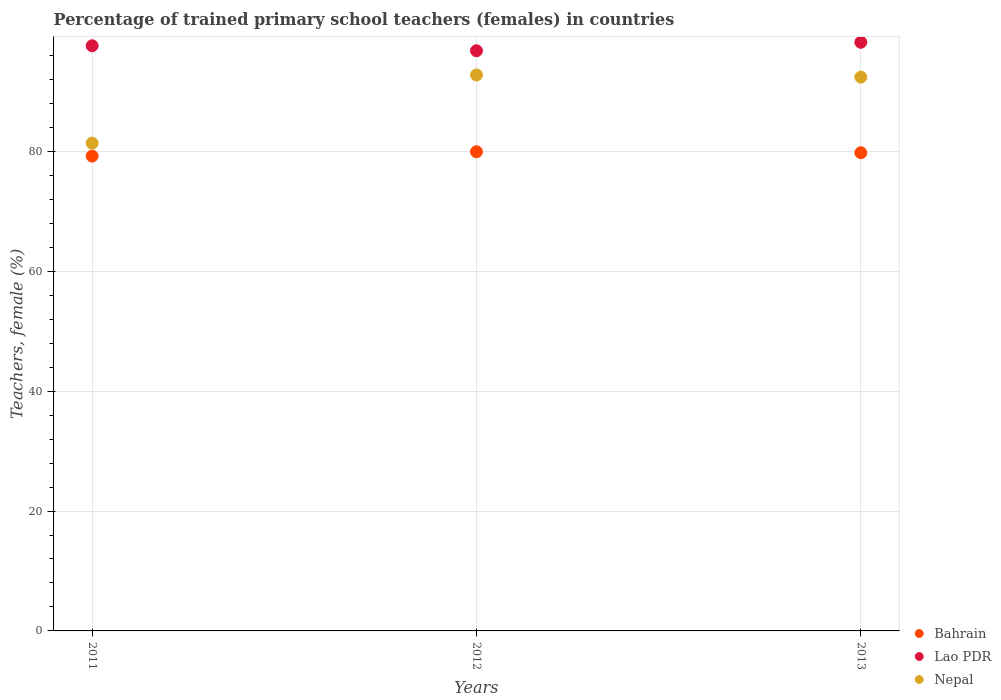What is the percentage of trained primary school teachers (females) in Lao PDR in 2013?
Your response must be concise. 98.19. Across all years, what is the maximum percentage of trained primary school teachers (females) in Nepal?
Give a very brief answer. 92.74. Across all years, what is the minimum percentage of trained primary school teachers (females) in Lao PDR?
Offer a terse response. 96.78. In which year was the percentage of trained primary school teachers (females) in Nepal maximum?
Ensure brevity in your answer.  2012. In which year was the percentage of trained primary school teachers (females) in Nepal minimum?
Offer a terse response. 2011. What is the total percentage of trained primary school teachers (females) in Bahrain in the graph?
Give a very brief answer. 238.91. What is the difference between the percentage of trained primary school teachers (females) in Nepal in 2012 and that in 2013?
Offer a terse response. 0.36. What is the difference between the percentage of trained primary school teachers (females) in Nepal in 2013 and the percentage of trained primary school teachers (females) in Lao PDR in 2012?
Ensure brevity in your answer.  -4.4. What is the average percentage of trained primary school teachers (females) in Lao PDR per year?
Ensure brevity in your answer.  97.53. In the year 2011, what is the difference between the percentage of trained primary school teachers (females) in Nepal and percentage of trained primary school teachers (females) in Bahrain?
Your response must be concise. 2.17. What is the ratio of the percentage of trained primary school teachers (females) in Bahrain in 2011 to that in 2013?
Give a very brief answer. 0.99. What is the difference between the highest and the second highest percentage of trained primary school teachers (females) in Bahrain?
Provide a succinct answer. 0.16. What is the difference between the highest and the lowest percentage of trained primary school teachers (females) in Lao PDR?
Provide a succinct answer. 1.42. Is the sum of the percentage of trained primary school teachers (females) in Lao PDR in 2011 and 2012 greater than the maximum percentage of trained primary school teachers (females) in Bahrain across all years?
Offer a very short reply. Yes. Is it the case that in every year, the sum of the percentage of trained primary school teachers (females) in Nepal and percentage of trained primary school teachers (females) in Bahrain  is greater than the percentage of trained primary school teachers (females) in Lao PDR?
Provide a succinct answer. Yes. Is the percentage of trained primary school teachers (females) in Lao PDR strictly less than the percentage of trained primary school teachers (females) in Bahrain over the years?
Provide a succinct answer. No. What is the difference between two consecutive major ticks on the Y-axis?
Provide a short and direct response. 20. Does the graph contain any zero values?
Your answer should be compact. No. What is the title of the graph?
Your answer should be very brief. Percentage of trained primary school teachers (females) in countries. Does "Ecuador" appear as one of the legend labels in the graph?
Ensure brevity in your answer.  No. What is the label or title of the X-axis?
Give a very brief answer. Years. What is the label or title of the Y-axis?
Your answer should be very brief. Teachers, female (%). What is the Teachers, female (%) of Bahrain in 2011?
Keep it short and to the point. 79.2. What is the Teachers, female (%) in Lao PDR in 2011?
Make the answer very short. 97.61. What is the Teachers, female (%) of Nepal in 2011?
Offer a terse response. 81.37. What is the Teachers, female (%) in Bahrain in 2012?
Keep it short and to the point. 79.93. What is the Teachers, female (%) in Lao PDR in 2012?
Keep it short and to the point. 96.78. What is the Teachers, female (%) of Nepal in 2012?
Give a very brief answer. 92.74. What is the Teachers, female (%) of Bahrain in 2013?
Your response must be concise. 79.77. What is the Teachers, female (%) in Lao PDR in 2013?
Make the answer very short. 98.19. What is the Teachers, female (%) in Nepal in 2013?
Your response must be concise. 92.38. Across all years, what is the maximum Teachers, female (%) of Bahrain?
Give a very brief answer. 79.93. Across all years, what is the maximum Teachers, female (%) in Lao PDR?
Ensure brevity in your answer.  98.19. Across all years, what is the maximum Teachers, female (%) in Nepal?
Ensure brevity in your answer.  92.74. Across all years, what is the minimum Teachers, female (%) of Bahrain?
Keep it short and to the point. 79.2. Across all years, what is the minimum Teachers, female (%) in Lao PDR?
Offer a very short reply. 96.78. Across all years, what is the minimum Teachers, female (%) in Nepal?
Offer a very short reply. 81.37. What is the total Teachers, female (%) of Bahrain in the graph?
Provide a succinct answer. 238.91. What is the total Teachers, female (%) in Lao PDR in the graph?
Provide a succinct answer. 292.59. What is the total Teachers, female (%) in Nepal in the graph?
Provide a short and direct response. 266.49. What is the difference between the Teachers, female (%) of Bahrain in 2011 and that in 2012?
Your answer should be compact. -0.73. What is the difference between the Teachers, female (%) in Lao PDR in 2011 and that in 2012?
Ensure brevity in your answer.  0.83. What is the difference between the Teachers, female (%) in Nepal in 2011 and that in 2012?
Your answer should be very brief. -11.37. What is the difference between the Teachers, female (%) in Bahrain in 2011 and that in 2013?
Your response must be concise. -0.57. What is the difference between the Teachers, female (%) in Lao PDR in 2011 and that in 2013?
Your response must be concise. -0.58. What is the difference between the Teachers, female (%) in Nepal in 2011 and that in 2013?
Your response must be concise. -11.01. What is the difference between the Teachers, female (%) of Bahrain in 2012 and that in 2013?
Give a very brief answer. 0.16. What is the difference between the Teachers, female (%) in Lao PDR in 2012 and that in 2013?
Give a very brief answer. -1.42. What is the difference between the Teachers, female (%) of Nepal in 2012 and that in 2013?
Keep it short and to the point. 0.36. What is the difference between the Teachers, female (%) in Bahrain in 2011 and the Teachers, female (%) in Lao PDR in 2012?
Provide a short and direct response. -17.58. What is the difference between the Teachers, female (%) of Bahrain in 2011 and the Teachers, female (%) of Nepal in 2012?
Your answer should be compact. -13.53. What is the difference between the Teachers, female (%) in Lao PDR in 2011 and the Teachers, female (%) in Nepal in 2012?
Your answer should be very brief. 4.87. What is the difference between the Teachers, female (%) in Bahrain in 2011 and the Teachers, female (%) in Lao PDR in 2013?
Make the answer very short. -18.99. What is the difference between the Teachers, female (%) of Bahrain in 2011 and the Teachers, female (%) of Nepal in 2013?
Your answer should be compact. -13.18. What is the difference between the Teachers, female (%) of Lao PDR in 2011 and the Teachers, female (%) of Nepal in 2013?
Your answer should be compact. 5.23. What is the difference between the Teachers, female (%) in Bahrain in 2012 and the Teachers, female (%) in Lao PDR in 2013?
Your response must be concise. -18.26. What is the difference between the Teachers, female (%) in Bahrain in 2012 and the Teachers, female (%) in Nepal in 2013?
Provide a succinct answer. -12.45. What is the difference between the Teachers, female (%) of Lao PDR in 2012 and the Teachers, female (%) of Nepal in 2013?
Ensure brevity in your answer.  4.4. What is the average Teachers, female (%) in Bahrain per year?
Your answer should be compact. 79.64. What is the average Teachers, female (%) in Lao PDR per year?
Keep it short and to the point. 97.53. What is the average Teachers, female (%) of Nepal per year?
Keep it short and to the point. 88.83. In the year 2011, what is the difference between the Teachers, female (%) of Bahrain and Teachers, female (%) of Lao PDR?
Provide a succinct answer. -18.41. In the year 2011, what is the difference between the Teachers, female (%) in Bahrain and Teachers, female (%) in Nepal?
Make the answer very short. -2.17. In the year 2011, what is the difference between the Teachers, female (%) in Lao PDR and Teachers, female (%) in Nepal?
Provide a short and direct response. 16.24. In the year 2012, what is the difference between the Teachers, female (%) in Bahrain and Teachers, female (%) in Lao PDR?
Your answer should be very brief. -16.85. In the year 2012, what is the difference between the Teachers, female (%) in Bahrain and Teachers, female (%) in Nepal?
Make the answer very short. -12.81. In the year 2012, what is the difference between the Teachers, female (%) of Lao PDR and Teachers, female (%) of Nepal?
Your answer should be compact. 4.04. In the year 2013, what is the difference between the Teachers, female (%) in Bahrain and Teachers, female (%) in Lao PDR?
Ensure brevity in your answer.  -18.42. In the year 2013, what is the difference between the Teachers, female (%) of Bahrain and Teachers, female (%) of Nepal?
Offer a very short reply. -12.61. In the year 2013, what is the difference between the Teachers, female (%) in Lao PDR and Teachers, female (%) in Nepal?
Your answer should be very brief. 5.82. What is the ratio of the Teachers, female (%) of Bahrain in 2011 to that in 2012?
Keep it short and to the point. 0.99. What is the ratio of the Teachers, female (%) in Lao PDR in 2011 to that in 2012?
Give a very brief answer. 1.01. What is the ratio of the Teachers, female (%) in Nepal in 2011 to that in 2012?
Provide a succinct answer. 0.88. What is the ratio of the Teachers, female (%) of Bahrain in 2011 to that in 2013?
Your response must be concise. 0.99. What is the ratio of the Teachers, female (%) of Nepal in 2011 to that in 2013?
Provide a short and direct response. 0.88. What is the ratio of the Teachers, female (%) in Bahrain in 2012 to that in 2013?
Your answer should be very brief. 1. What is the ratio of the Teachers, female (%) of Lao PDR in 2012 to that in 2013?
Provide a succinct answer. 0.99. What is the difference between the highest and the second highest Teachers, female (%) of Bahrain?
Provide a short and direct response. 0.16. What is the difference between the highest and the second highest Teachers, female (%) in Lao PDR?
Ensure brevity in your answer.  0.58. What is the difference between the highest and the second highest Teachers, female (%) of Nepal?
Ensure brevity in your answer.  0.36. What is the difference between the highest and the lowest Teachers, female (%) in Bahrain?
Offer a very short reply. 0.73. What is the difference between the highest and the lowest Teachers, female (%) in Lao PDR?
Your answer should be compact. 1.42. What is the difference between the highest and the lowest Teachers, female (%) in Nepal?
Give a very brief answer. 11.37. 